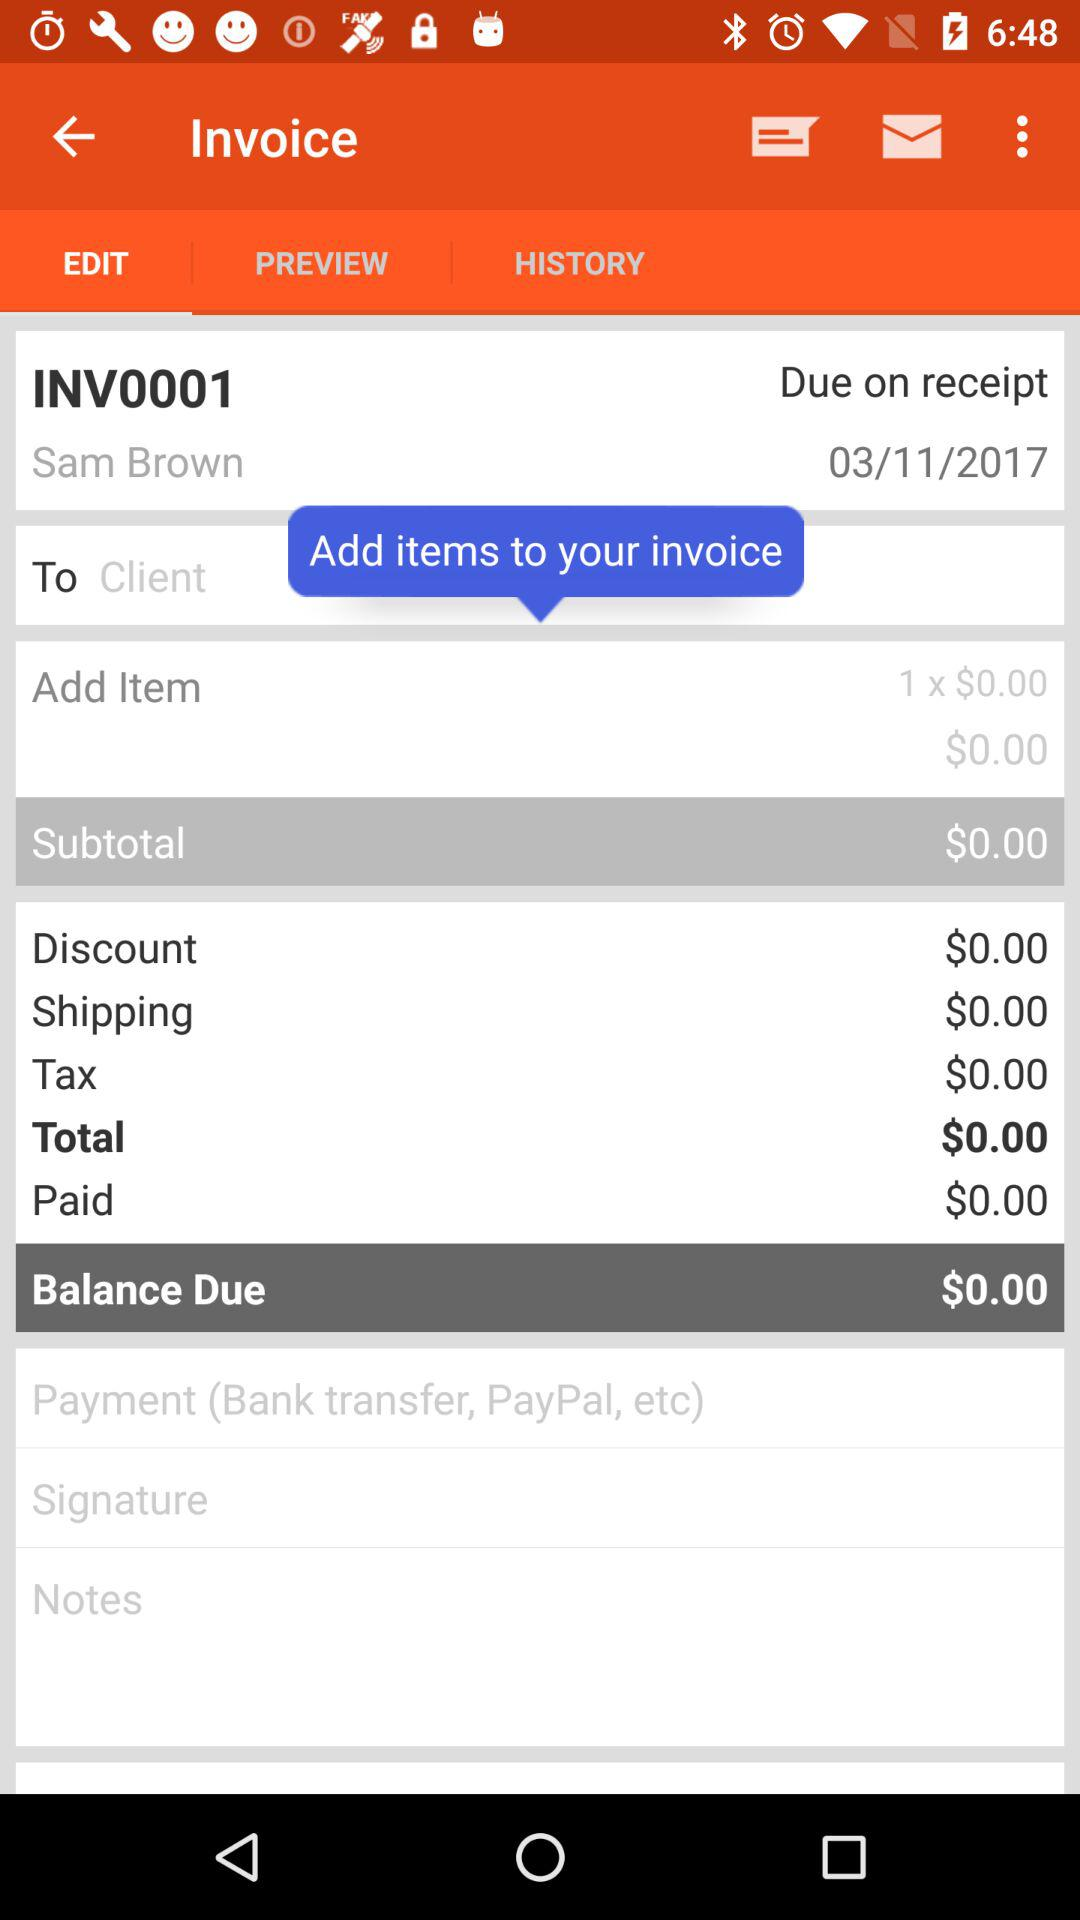What is the amount of tax? The amount of tax is $0. 